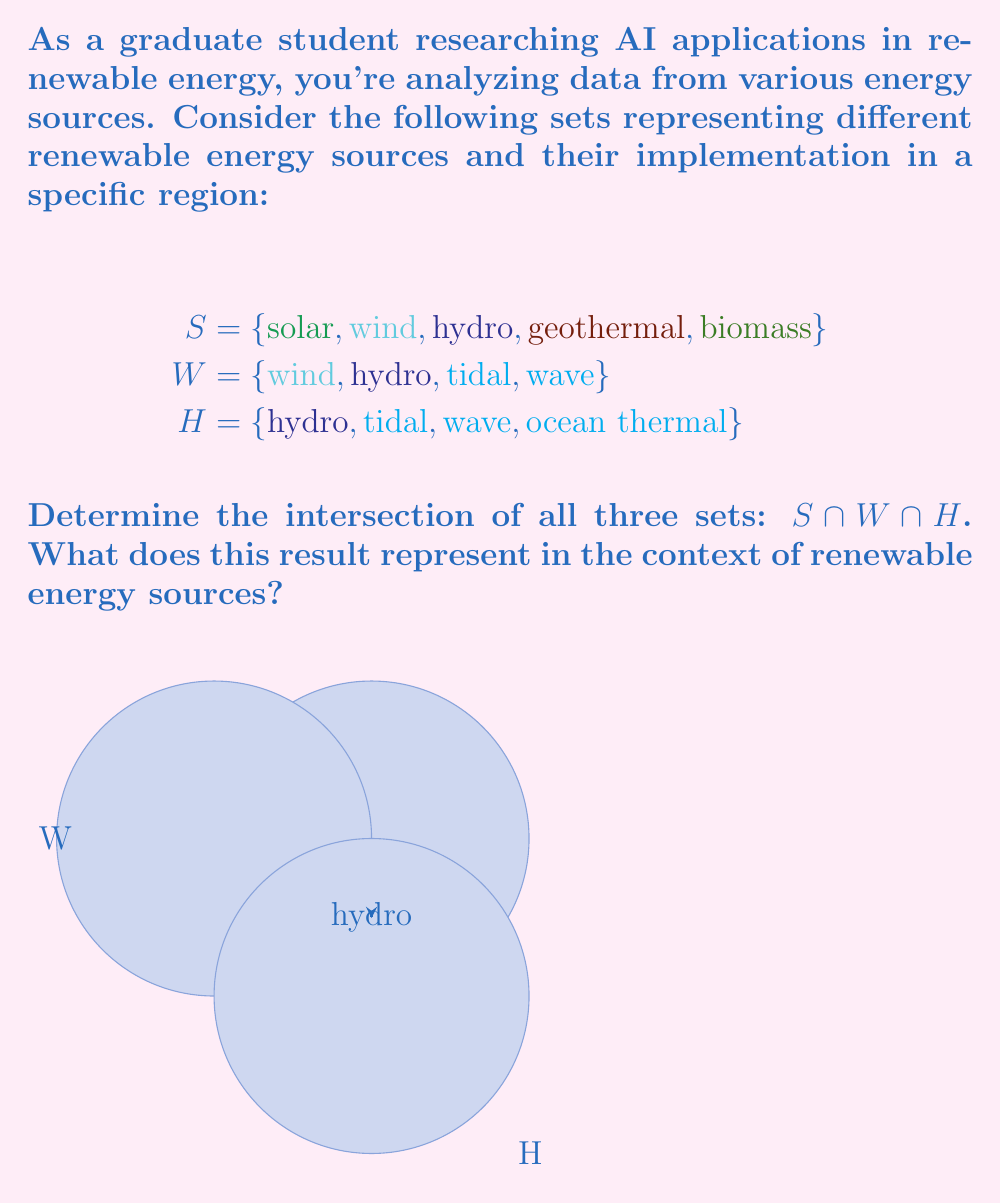Show me your answer to this math problem. To find the intersection of sets S, W, and H, we need to identify the elements that are common to all three sets. Let's approach this step-by-step:

1) First, let's list the elements of each set:
   $$\begin{align*}
   S &= \{\text{solar}, \text{wind}, \text{hydro}, \text{geothermal}, \text{biomass}\} \\
   W &= \{\text{wind}, \text{hydro}, \text{tidal}, \text{wave}\} \\
   H &= \{\text{hydro}, \text{tidal}, \text{wave}, \text{ocean thermal}\}
   \end{align*}$$

2) Now, let's find the elements that appear in all three sets:
   - "solar" is only in S
   - "wind" is in S and W, but not in H
   - "hydro" is in S, W, and H
   - "geothermal" is only in S
   - "biomass" is only in S
   - "tidal" is in W and H, but not in S
   - "wave" is in W and H, but not in S
   - "ocean thermal" is only in H

3) Therefore, the only element that appears in all three sets is "hydro".

4) We can express this mathematically as:
   $$S \cap W \cap H = \{\text{hydro}\}$$

In the context of renewable energy sources, this result represents the energy source that is common across all three categories defined by the sets. Hydropower (hydro) is the only energy source that appears in all three sets, indicating it's a versatile renewable energy source that spans multiple classifications in this particular analysis.
Answer: $\{\text{hydro}\}$ 